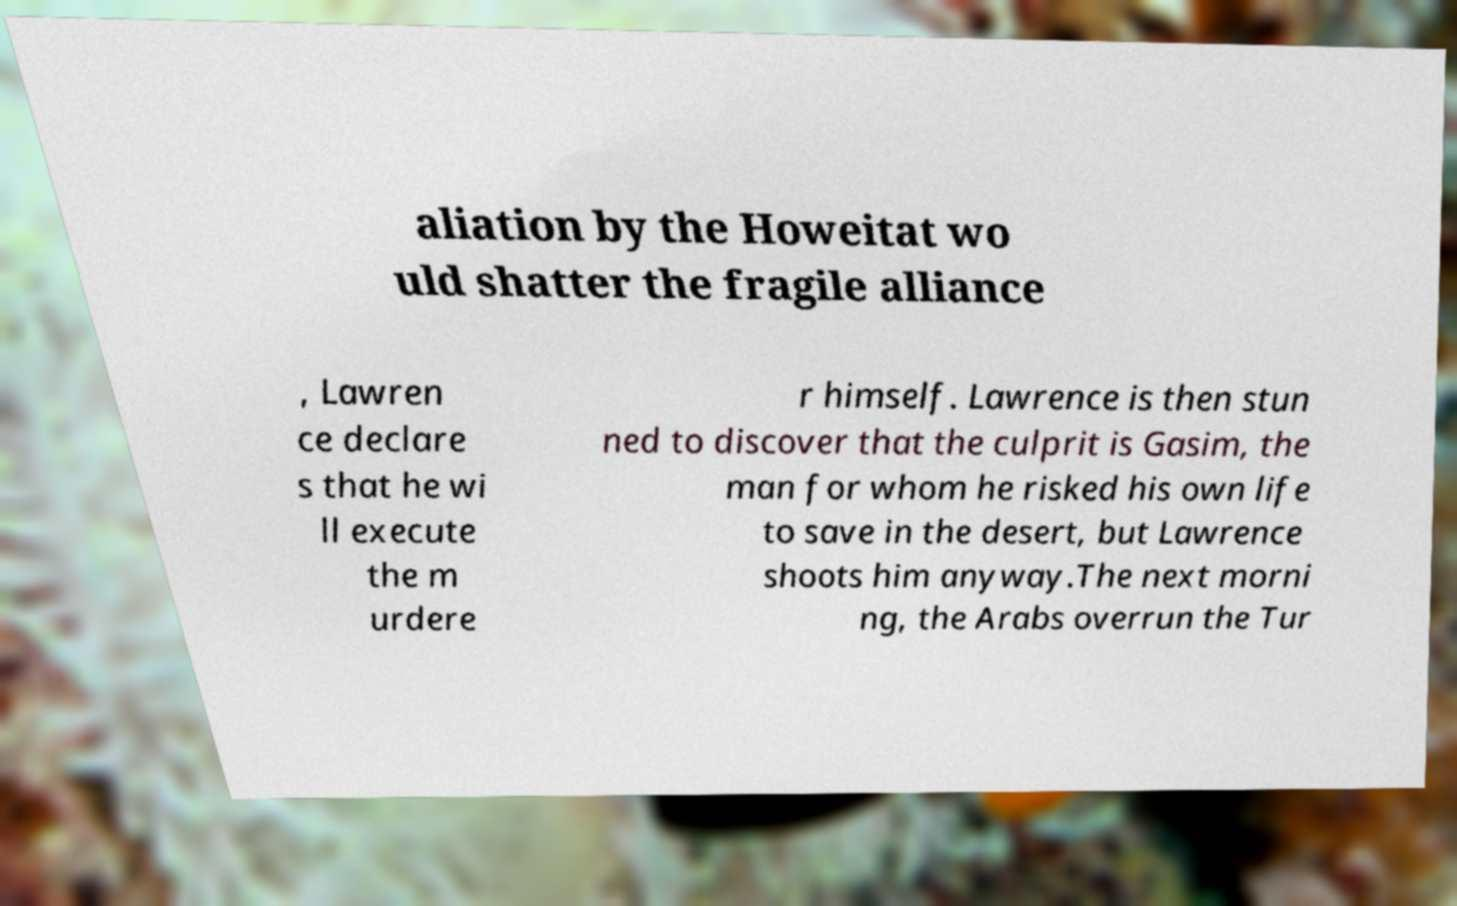Could you assist in decoding the text presented in this image and type it out clearly? aliation by the Howeitat wo uld shatter the fragile alliance , Lawren ce declare s that he wi ll execute the m urdere r himself. Lawrence is then stun ned to discover that the culprit is Gasim, the man for whom he risked his own life to save in the desert, but Lawrence shoots him anyway.The next morni ng, the Arabs overrun the Tur 